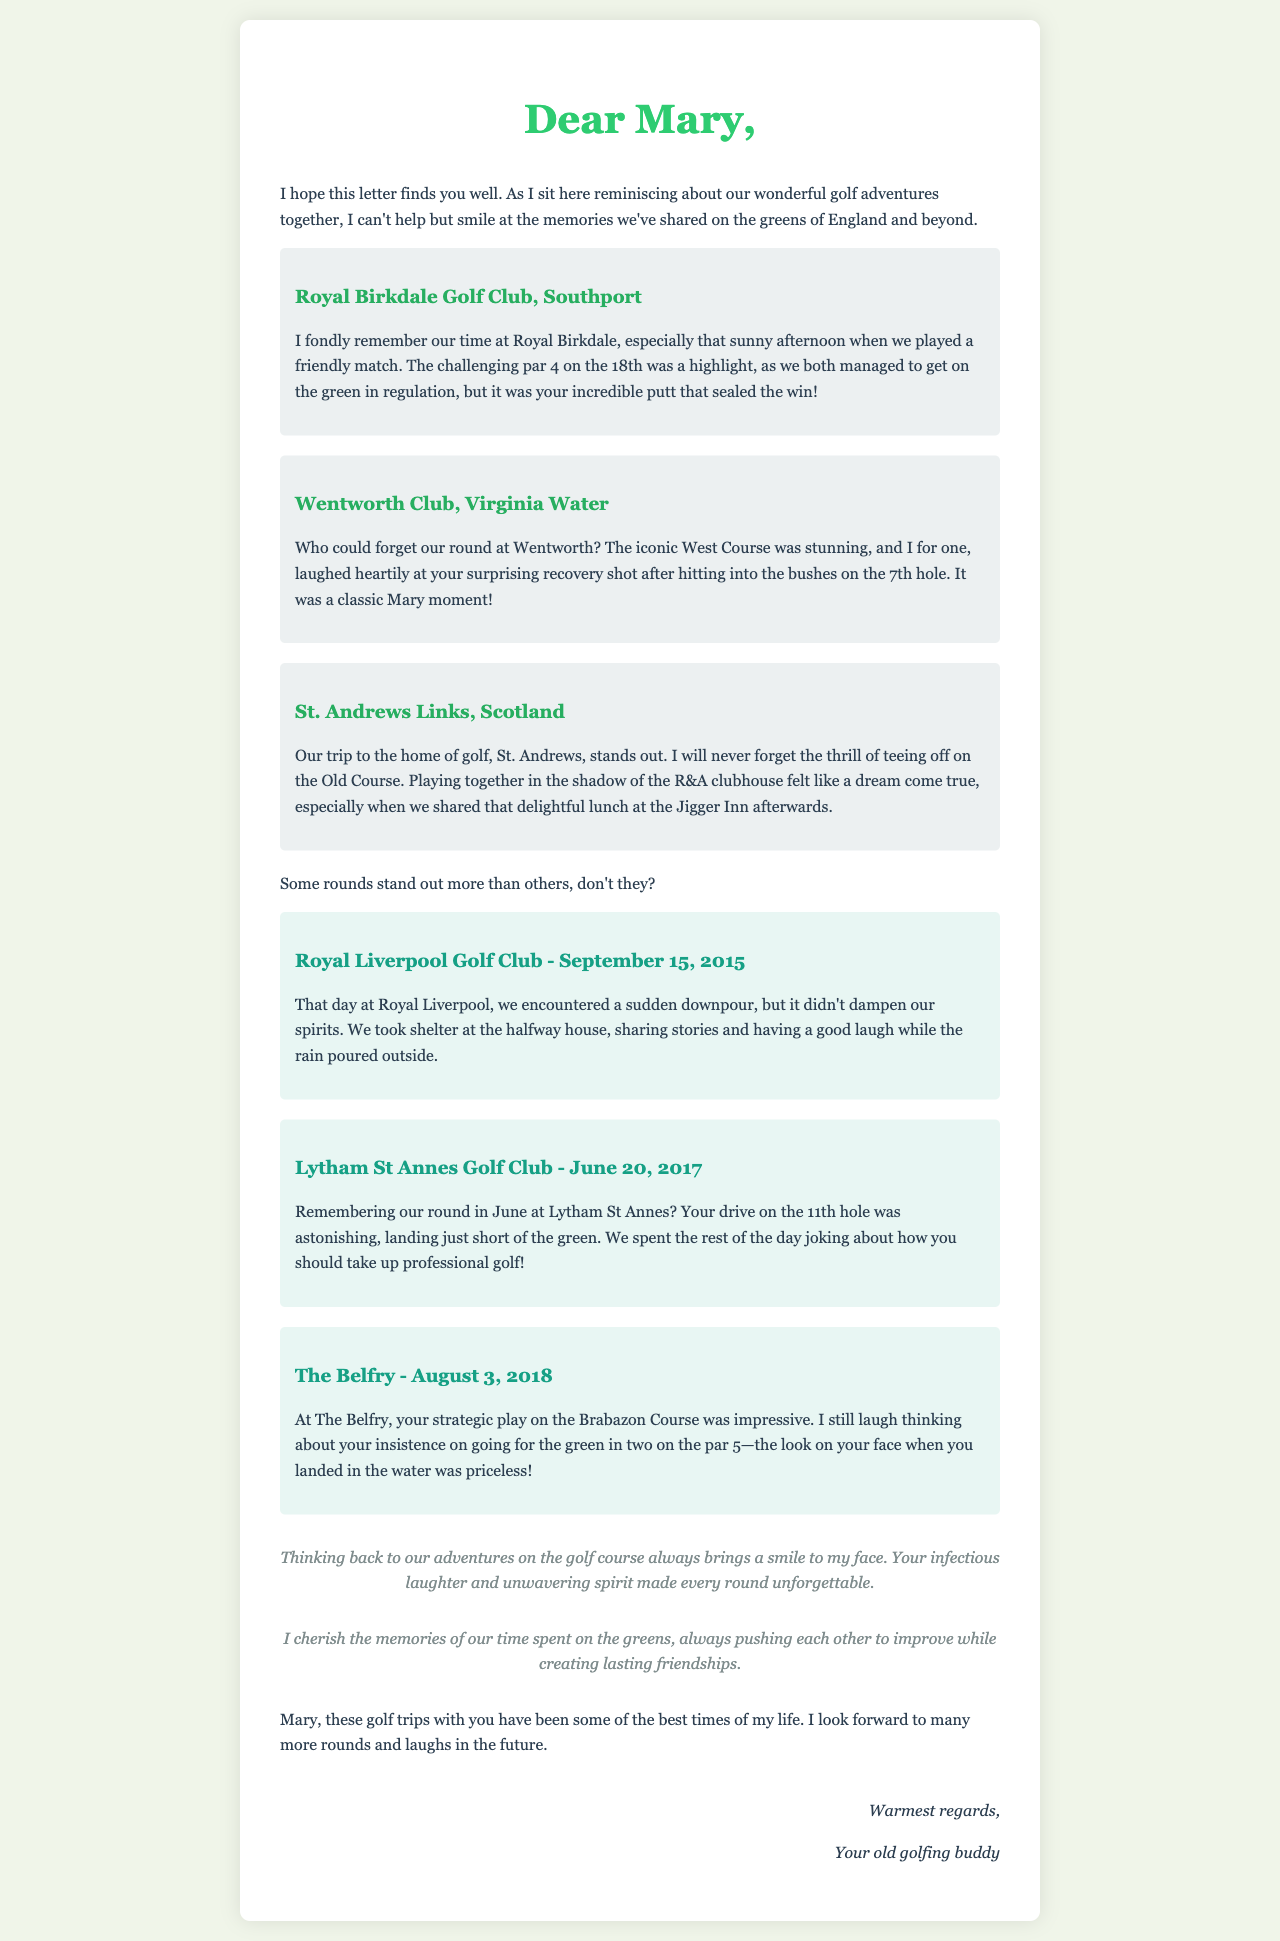what is the first golf course mentioned in the letter? The letter mentions Royal Birkdale Golf Club as the first course discussed.
Answer: Royal Birkdale Golf Club who performed a memorable putt at Royal Birkdale? The text highlights that Mary made an incredible putt that sealed the win during their match at Royal Birkdale.
Answer: Mary what was the date of the round at Royal Liverpool Golf Club? The letter specifies that the memorable round at Royal Liverpool occurred on September 15, 2015.
Answer: September 15, 2015 which course is referred to as the home of golf? The letter states that St. Andrews Links is referred to as the home of golf.
Answer: St. Andrews Links what memorable event occurred during the round at The Belfry? The letter recalls that the writer laughs about Mary landing in the water after attempting to go for the green in two on the par 5 at The Belfry.
Answer: Landing in the water how does the writer feel about the golf trips shared with Mary? The writer expresses that the golf trips with Mary have been some of the best times of their life.
Answer: Best times what was Mary's memorable recovery shot at Wentworth? The letter describes a classic moment where Mary hit into the bushes on the 7th hole but made a surprising recovery shot.
Answer: Recovery shot which golfing trip included a lunch at the Jigger Inn? The writer mentions that after playing at St. Andrews, they shared a delightful lunch at the Jigger Inn.
Answer: St. Andrews what emotion does the writer associate with the memories of playing golf with Mary? The writer states that reminiscing about golf adventures with Mary always brings a smile to their face.
Answer: Smile 